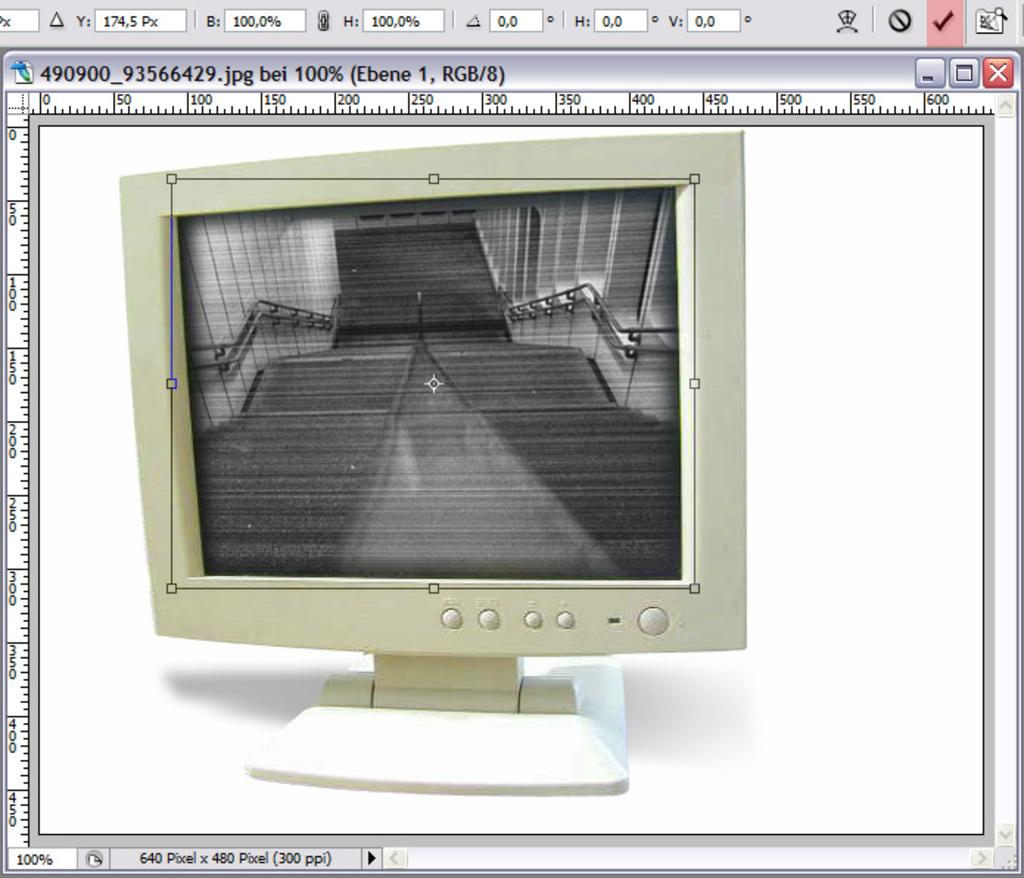Is this picture at 100%?
Give a very brief answer. Yes. In what type of format is this picture?
Keep it short and to the point. Answering does not require reading text in the image. 